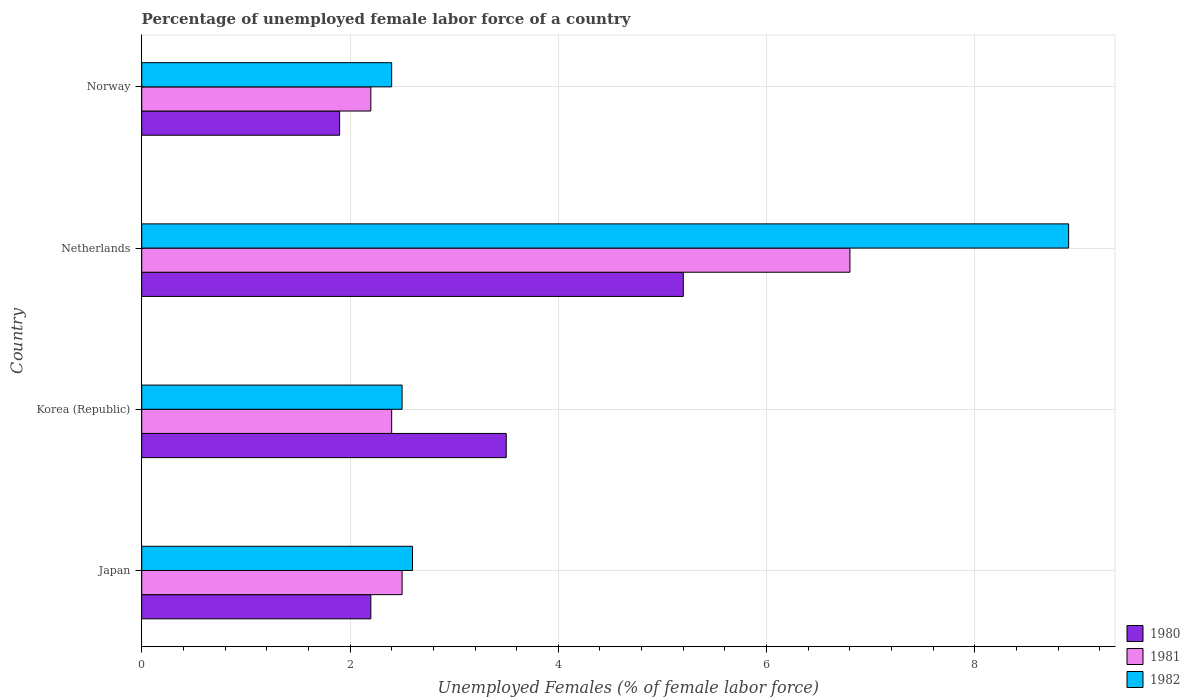How many different coloured bars are there?
Make the answer very short. 3. Are the number of bars on each tick of the Y-axis equal?
Ensure brevity in your answer.  Yes. What is the percentage of unemployed female labor force in 1982 in Netherlands?
Your answer should be compact. 8.9. Across all countries, what is the maximum percentage of unemployed female labor force in 1980?
Your answer should be very brief. 5.2. Across all countries, what is the minimum percentage of unemployed female labor force in 1980?
Offer a very short reply. 1.9. What is the total percentage of unemployed female labor force in 1981 in the graph?
Ensure brevity in your answer.  13.9. What is the difference between the percentage of unemployed female labor force in 1981 in Netherlands and that in Norway?
Make the answer very short. 4.6. What is the difference between the percentage of unemployed female labor force in 1980 in Netherlands and the percentage of unemployed female labor force in 1981 in Japan?
Offer a very short reply. 2.7. What is the average percentage of unemployed female labor force in 1982 per country?
Provide a short and direct response. 4.1. What is the difference between the percentage of unemployed female labor force in 1980 and percentage of unemployed female labor force in 1982 in Netherlands?
Make the answer very short. -3.7. In how many countries, is the percentage of unemployed female labor force in 1981 greater than 6.4 %?
Offer a terse response. 1. What is the ratio of the percentage of unemployed female labor force in 1980 in Korea (Republic) to that in Norway?
Provide a short and direct response. 1.84. Is the percentage of unemployed female labor force in 1981 in Korea (Republic) less than that in Netherlands?
Give a very brief answer. Yes. What is the difference between the highest and the second highest percentage of unemployed female labor force in 1981?
Make the answer very short. 4.3. What is the difference between the highest and the lowest percentage of unemployed female labor force in 1980?
Ensure brevity in your answer.  3.3. What does the 1st bar from the top in Netherlands represents?
Provide a succinct answer. 1982. What does the 1st bar from the bottom in Norway represents?
Your answer should be very brief. 1980. How many bars are there?
Make the answer very short. 12. What is the difference between two consecutive major ticks on the X-axis?
Your answer should be compact. 2. Does the graph contain any zero values?
Provide a short and direct response. No. Does the graph contain grids?
Your response must be concise. Yes. Where does the legend appear in the graph?
Your answer should be very brief. Bottom right. How many legend labels are there?
Make the answer very short. 3. What is the title of the graph?
Your answer should be compact. Percentage of unemployed female labor force of a country. What is the label or title of the X-axis?
Keep it short and to the point. Unemployed Females (% of female labor force). What is the Unemployed Females (% of female labor force) in 1980 in Japan?
Offer a very short reply. 2.2. What is the Unemployed Females (% of female labor force) of 1982 in Japan?
Make the answer very short. 2.6. What is the Unemployed Females (% of female labor force) in 1980 in Korea (Republic)?
Offer a very short reply. 3.5. What is the Unemployed Females (% of female labor force) of 1981 in Korea (Republic)?
Your answer should be very brief. 2.4. What is the Unemployed Females (% of female labor force) in 1982 in Korea (Republic)?
Provide a short and direct response. 2.5. What is the Unemployed Females (% of female labor force) in 1980 in Netherlands?
Keep it short and to the point. 5.2. What is the Unemployed Females (% of female labor force) in 1981 in Netherlands?
Your response must be concise. 6.8. What is the Unemployed Females (% of female labor force) in 1982 in Netherlands?
Ensure brevity in your answer.  8.9. What is the Unemployed Females (% of female labor force) in 1980 in Norway?
Your response must be concise. 1.9. What is the Unemployed Females (% of female labor force) of 1981 in Norway?
Your answer should be very brief. 2.2. What is the Unemployed Females (% of female labor force) of 1982 in Norway?
Offer a terse response. 2.4. Across all countries, what is the maximum Unemployed Females (% of female labor force) in 1980?
Offer a terse response. 5.2. Across all countries, what is the maximum Unemployed Females (% of female labor force) of 1981?
Provide a succinct answer. 6.8. Across all countries, what is the maximum Unemployed Females (% of female labor force) in 1982?
Provide a short and direct response. 8.9. Across all countries, what is the minimum Unemployed Females (% of female labor force) in 1980?
Your response must be concise. 1.9. Across all countries, what is the minimum Unemployed Females (% of female labor force) of 1981?
Your answer should be compact. 2.2. Across all countries, what is the minimum Unemployed Females (% of female labor force) in 1982?
Provide a succinct answer. 2.4. What is the difference between the Unemployed Females (% of female labor force) of 1981 in Japan and that in Korea (Republic)?
Provide a succinct answer. 0.1. What is the difference between the Unemployed Females (% of female labor force) in 1982 in Japan and that in Korea (Republic)?
Ensure brevity in your answer.  0.1. What is the difference between the Unemployed Females (% of female labor force) of 1980 in Japan and that in Netherlands?
Give a very brief answer. -3. What is the difference between the Unemployed Females (% of female labor force) of 1982 in Japan and that in Netherlands?
Your response must be concise. -6.3. What is the difference between the Unemployed Females (% of female labor force) of 1980 in Japan and that in Norway?
Offer a very short reply. 0.3. What is the difference between the Unemployed Females (% of female labor force) of 1982 in Korea (Republic) and that in Netherlands?
Provide a short and direct response. -6.4. What is the difference between the Unemployed Females (% of female labor force) in 1981 in Korea (Republic) and that in Norway?
Offer a terse response. 0.2. What is the difference between the Unemployed Females (% of female labor force) in 1982 in Korea (Republic) and that in Norway?
Your answer should be very brief. 0.1. What is the difference between the Unemployed Females (% of female labor force) in 1980 in Japan and the Unemployed Females (% of female labor force) in 1981 in Netherlands?
Offer a very short reply. -4.6. What is the difference between the Unemployed Females (% of female labor force) in 1980 in Japan and the Unemployed Females (% of female labor force) in 1981 in Norway?
Give a very brief answer. 0. What is the difference between the Unemployed Females (% of female labor force) in 1980 in Japan and the Unemployed Females (% of female labor force) in 1982 in Norway?
Your answer should be very brief. -0.2. What is the difference between the Unemployed Females (% of female labor force) in 1981 in Japan and the Unemployed Females (% of female labor force) in 1982 in Norway?
Ensure brevity in your answer.  0.1. What is the difference between the Unemployed Females (% of female labor force) of 1980 in Korea (Republic) and the Unemployed Females (% of female labor force) of 1981 in Netherlands?
Your response must be concise. -3.3. What is the difference between the Unemployed Females (% of female labor force) of 1981 in Korea (Republic) and the Unemployed Females (% of female labor force) of 1982 in Netherlands?
Offer a terse response. -6.5. What is the difference between the Unemployed Females (% of female labor force) in 1981 in Korea (Republic) and the Unemployed Females (% of female labor force) in 1982 in Norway?
Give a very brief answer. 0. What is the difference between the Unemployed Females (% of female labor force) in 1980 in Netherlands and the Unemployed Females (% of female labor force) in 1981 in Norway?
Your answer should be compact. 3. What is the difference between the Unemployed Females (% of female labor force) in 1980 in Netherlands and the Unemployed Females (% of female labor force) in 1982 in Norway?
Keep it short and to the point. 2.8. What is the average Unemployed Females (% of female labor force) of 1980 per country?
Offer a terse response. 3.2. What is the average Unemployed Females (% of female labor force) in 1981 per country?
Make the answer very short. 3.48. What is the average Unemployed Females (% of female labor force) in 1982 per country?
Keep it short and to the point. 4.1. What is the difference between the Unemployed Females (% of female labor force) of 1980 and Unemployed Females (% of female labor force) of 1981 in Japan?
Your response must be concise. -0.3. What is the difference between the Unemployed Females (% of female labor force) of 1980 and Unemployed Females (% of female labor force) of 1982 in Japan?
Give a very brief answer. -0.4. What is the difference between the Unemployed Females (% of female labor force) of 1981 and Unemployed Females (% of female labor force) of 1982 in Japan?
Give a very brief answer. -0.1. What is the difference between the Unemployed Females (% of female labor force) in 1980 and Unemployed Females (% of female labor force) in 1981 in Korea (Republic)?
Provide a short and direct response. 1.1. What is the difference between the Unemployed Females (% of female labor force) in 1980 and Unemployed Females (% of female labor force) in 1982 in Korea (Republic)?
Offer a terse response. 1. What is the difference between the Unemployed Females (% of female labor force) in 1981 and Unemployed Females (% of female labor force) in 1982 in Korea (Republic)?
Ensure brevity in your answer.  -0.1. What is the difference between the Unemployed Females (% of female labor force) of 1980 and Unemployed Females (% of female labor force) of 1981 in Netherlands?
Provide a succinct answer. -1.6. What is the difference between the Unemployed Females (% of female labor force) of 1980 and Unemployed Females (% of female labor force) of 1982 in Netherlands?
Keep it short and to the point. -3.7. What is the difference between the Unemployed Females (% of female labor force) of 1981 and Unemployed Females (% of female labor force) of 1982 in Netherlands?
Your response must be concise. -2.1. What is the difference between the Unemployed Females (% of female labor force) of 1980 and Unemployed Females (% of female labor force) of 1981 in Norway?
Provide a short and direct response. -0.3. What is the difference between the Unemployed Females (% of female labor force) in 1981 and Unemployed Females (% of female labor force) in 1982 in Norway?
Your answer should be very brief. -0.2. What is the ratio of the Unemployed Females (% of female labor force) in 1980 in Japan to that in Korea (Republic)?
Make the answer very short. 0.63. What is the ratio of the Unemployed Females (% of female labor force) of 1981 in Japan to that in Korea (Republic)?
Offer a very short reply. 1.04. What is the ratio of the Unemployed Females (% of female labor force) in 1982 in Japan to that in Korea (Republic)?
Give a very brief answer. 1.04. What is the ratio of the Unemployed Females (% of female labor force) in 1980 in Japan to that in Netherlands?
Offer a terse response. 0.42. What is the ratio of the Unemployed Females (% of female labor force) of 1981 in Japan to that in Netherlands?
Offer a very short reply. 0.37. What is the ratio of the Unemployed Females (% of female labor force) in 1982 in Japan to that in Netherlands?
Make the answer very short. 0.29. What is the ratio of the Unemployed Females (% of female labor force) in 1980 in Japan to that in Norway?
Your answer should be compact. 1.16. What is the ratio of the Unemployed Females (% of female labor force) in 1981 in Japan to that in Norway?
Give a very brief answer. 1.14. What is the ratio of the Unemployed Females (% of female labor force) in 1982 in Japan to that in Norway?
Provide a short and direct response. 1.08. What is the ratio of the Unemployed Females (% of female labor force) of 1980 in Korea (Republic) to that in Netherlands?
Ensure brevity in your answer.  0.67. What is the ratio of the Unemployed Females (% of female labor force) of 1981 in Korea (Republic) to that in Netherlands?
Offer a very short reply. 0.35. What is the ratio of the Unemployed Females (% of female labor force) of 1982 in Korea (Republic) to that in Netherlands?
Make the answer very short. 0.28. What is the ratio of the Unemployed Females (% of female labor force) of 1980 in Korea (Republic) to that in Norway?
Offer a terse response. 1.84. What is the ratio of the Unemployed Females (% of female labor force) in 1982 in Korea (Republic) to that in Norway?
Your answer should be compact. 1.04. What is the ratio of the Unemployed Females (% of female labor force) in 1980 in Netherlands to that in Norway?
Offer a terse response. 2.74. What is the ratio of the Unemployed Females (% of female labor force) in 1981 in Netherlands to that in Norway?
Offer a terse response. 3.09. What is the ratio of the Unemployed Females (% of female labor force) in 1982 in Netherlands to that in Norway?
Offer a terse response. 3.71. What is the difference between the highest and the second highest Unemployed Females (% of female labor force) in 1981?
Provide a succinct answer. 4.3. 